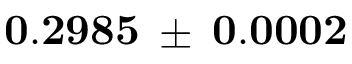Convert formula to latex. <formula><loc_0><loc_0><loc_500><loc_500>0 . 2 9 8 5 \, \pm { \, 0 . 0 0 0 2 }</formula> 